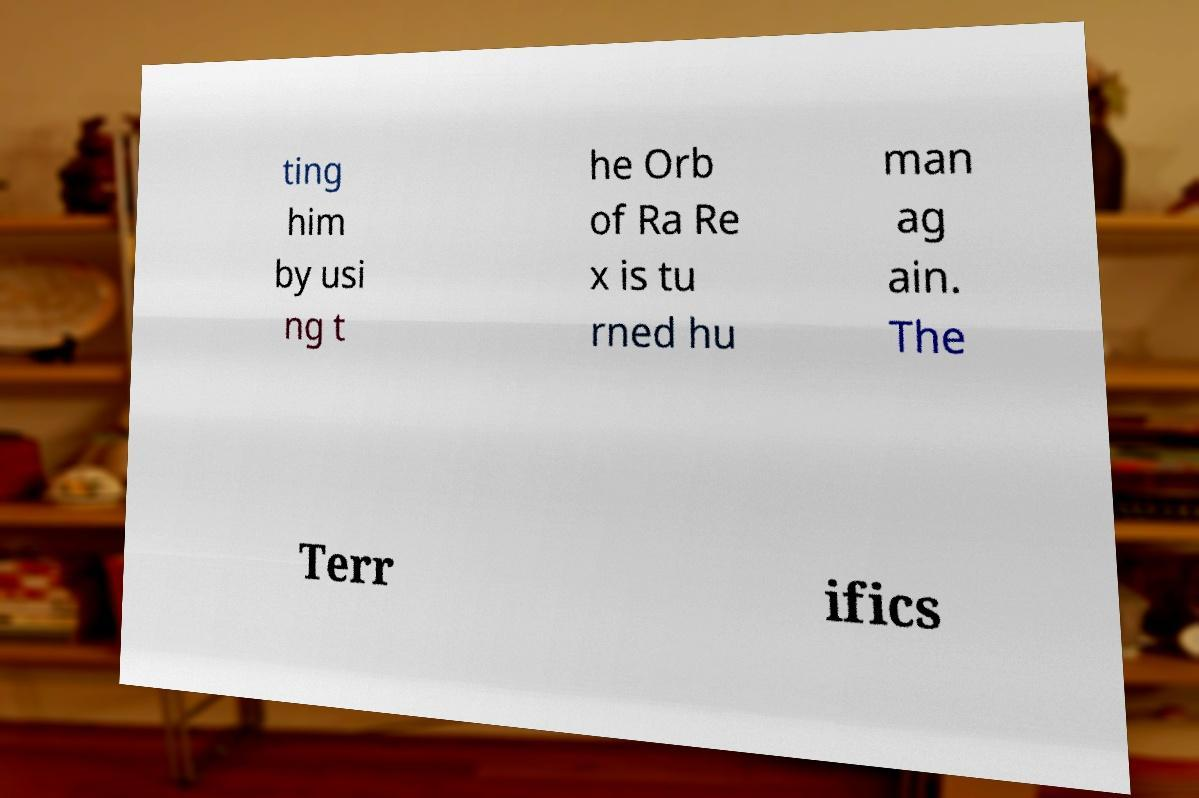Could you assist in decoding the text presented in this image and type it out clearly? ting him by usi ng t he Orb of Ra Re x is tu rned hu man ag ain. The Terr ifics 